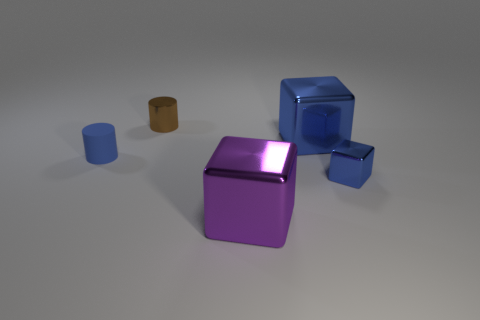Are there any purple blocks that are behind the blue shiny cube that is behind the small metallic thing on the right side of the big purple shiny thing?
Provide a succinct answer. No. What is the color of the tiny block that is the same material as the small brown object?
Make the answer very short. Blue. Do the small thing that is in front of the tiny blue cylinder and the matte object have the same color?
Give a very brief answer. Yes. How many balls are purple metallic objects or tiny brown metal objects?
Your response must be concise. 0. How big is the cube to the right of the large cube that is on the right side of the big cube on the left side of the big blue shiny block?
Your answer should be very brief. Small. There is a matte object that is the same size as the brown shiny thing; what is its shape?
Your response must be concise. Cylinder. What is the shape of the tiny brown metal thing?
Offer a very short reply. Cylinder. Does the large thing that is behind the tiny cube have the same material as the purple block?
Make the answer very short. Yes. There is a metal object that is on the left side of the big thing that is in front of the tiny blue cube; what is its size?
Make the answer very short. Small. What color is the small thing that is both in front of the brown metallic object and right of the tiny blue matte object?
Offer a very short reply. Blue. 